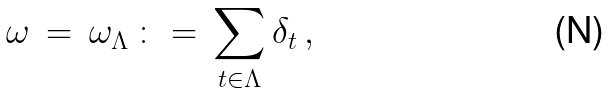<formula> <loc_0><loc_0><loc_500><loc_500>\omega \, = \, \omega _ { \Lambda } \, \colon = \, \sum _ { t \in \Lambda } \delta _ { t } \, ,</formula> 